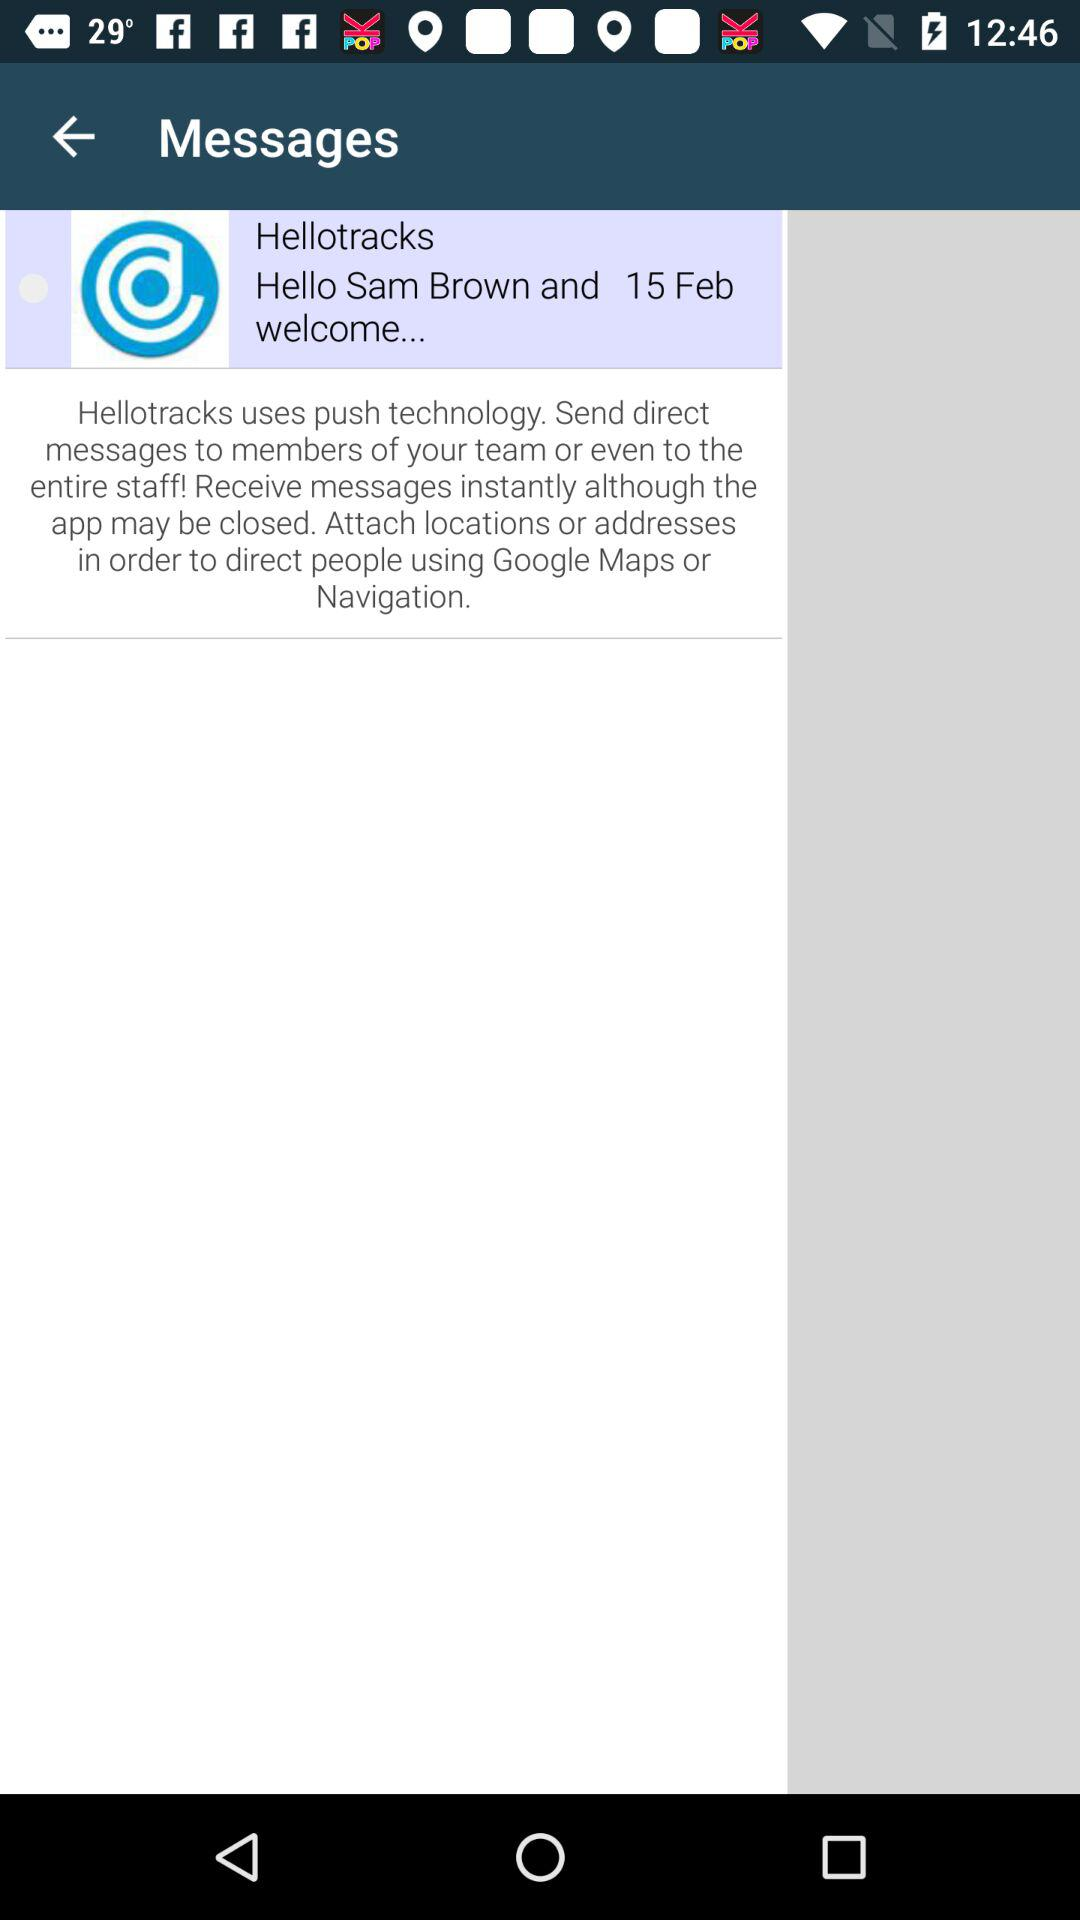What is the user name? The user name is Sam Brown. 